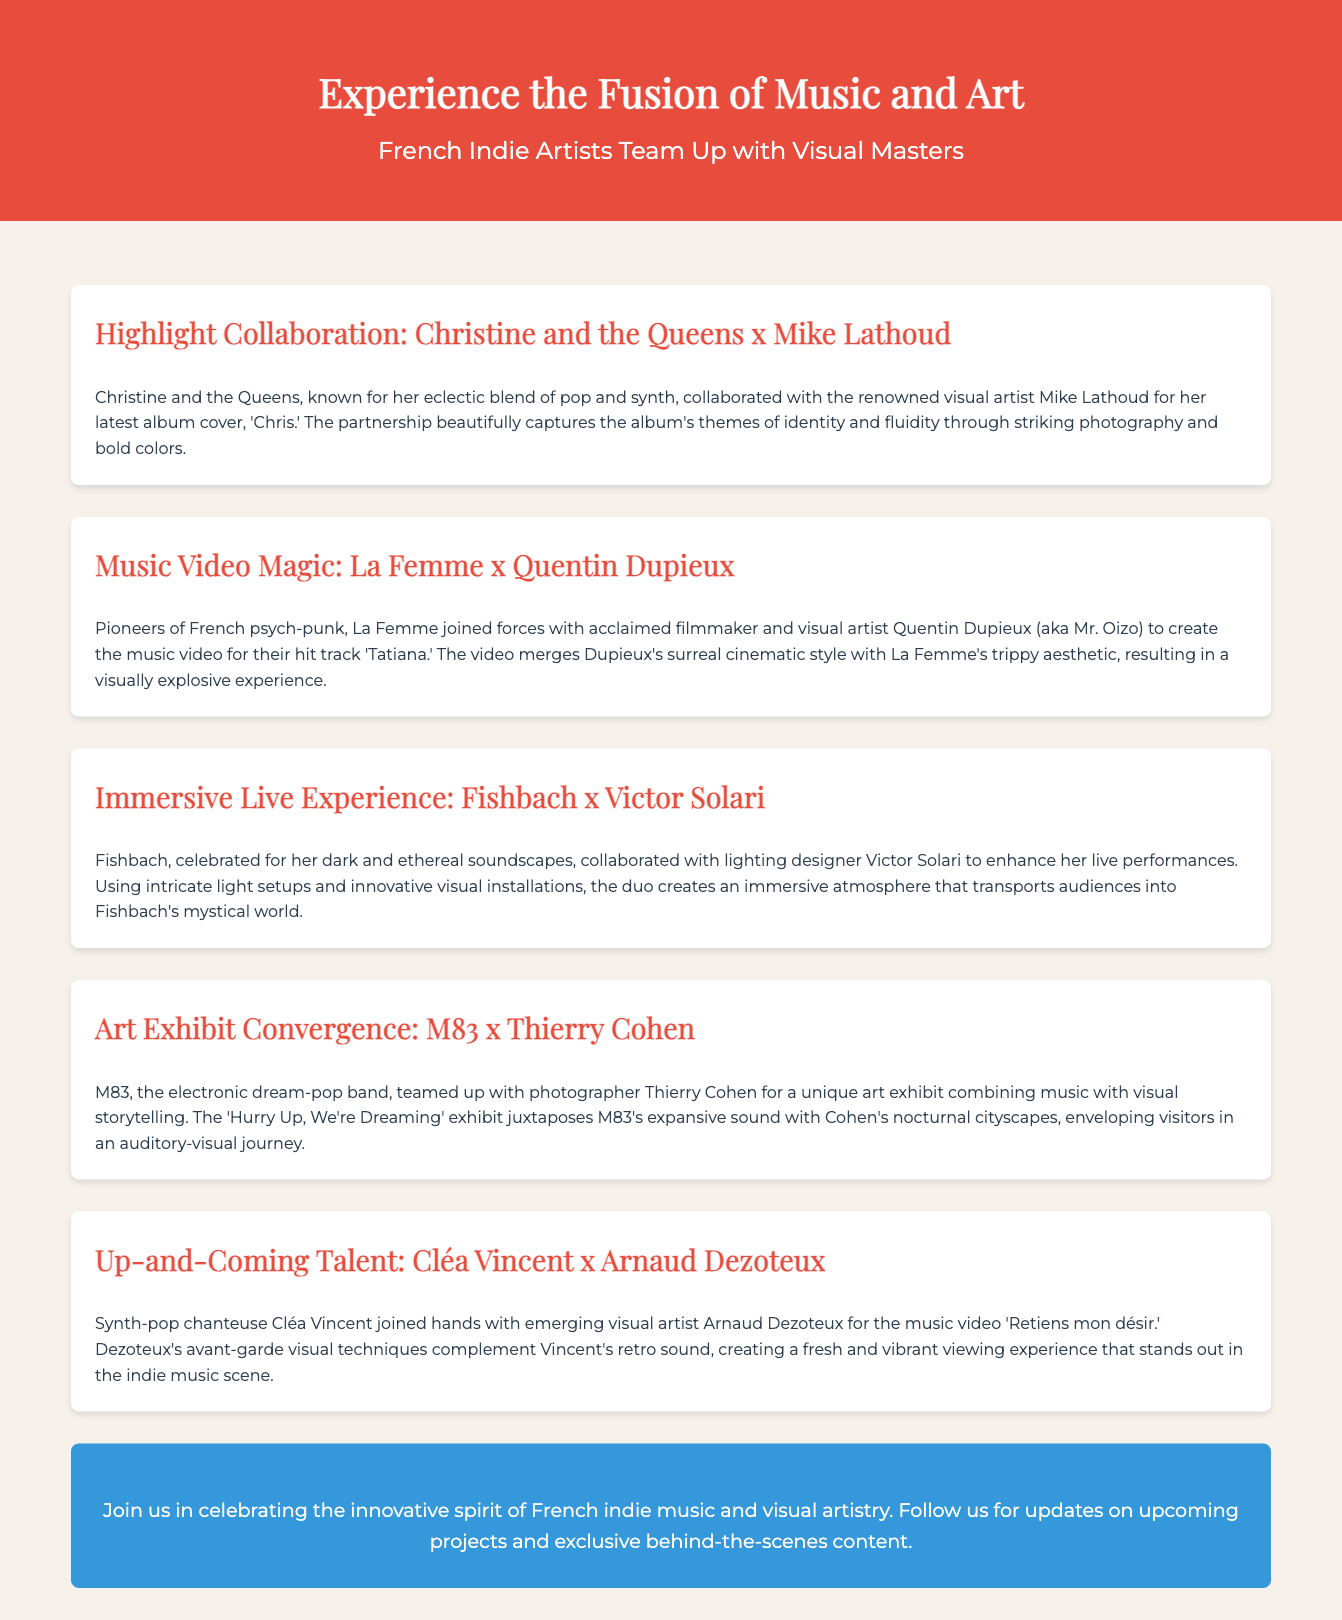What is the title of the advertisement? The title is the main heading of the document, found at the top.
Answer: Experience the Fusion of Music and Art Who collaborated with Christine and the Queens for the album cover? This information is found in the first collaboration section, detailing the partnership.
Answer: Mike Lathoud Which band partnered with Quentin Dupieux for a music video? This question seeks to identify the collaboration mentioned under music video magic.
Answer: La Femme What is the name of the song associated with Cléa Vincent and Arnaud Dezoteux? The document indicates the specific song in the collaboration section about them.
Answer: Retiens mon désir What type of artist is Victor Solari? The response requires understanding the role of Victor Solari in the collaboration with Fishbach.
Answer: Lighting designer Which visual artist worked with M83 for an art exhibit? This relates to the specific collaboration detailed in the art exhibit convergence section.
Answer: Thierry Cohen What is the focus of the advertisement? This aims to summarize the main theme and intention of the document.
Answer: Collaborations between musicians and visual artists How many collaborations are highlighted in the document? A count is needed based on the number of collaborations mentioned.
Answer: Five 